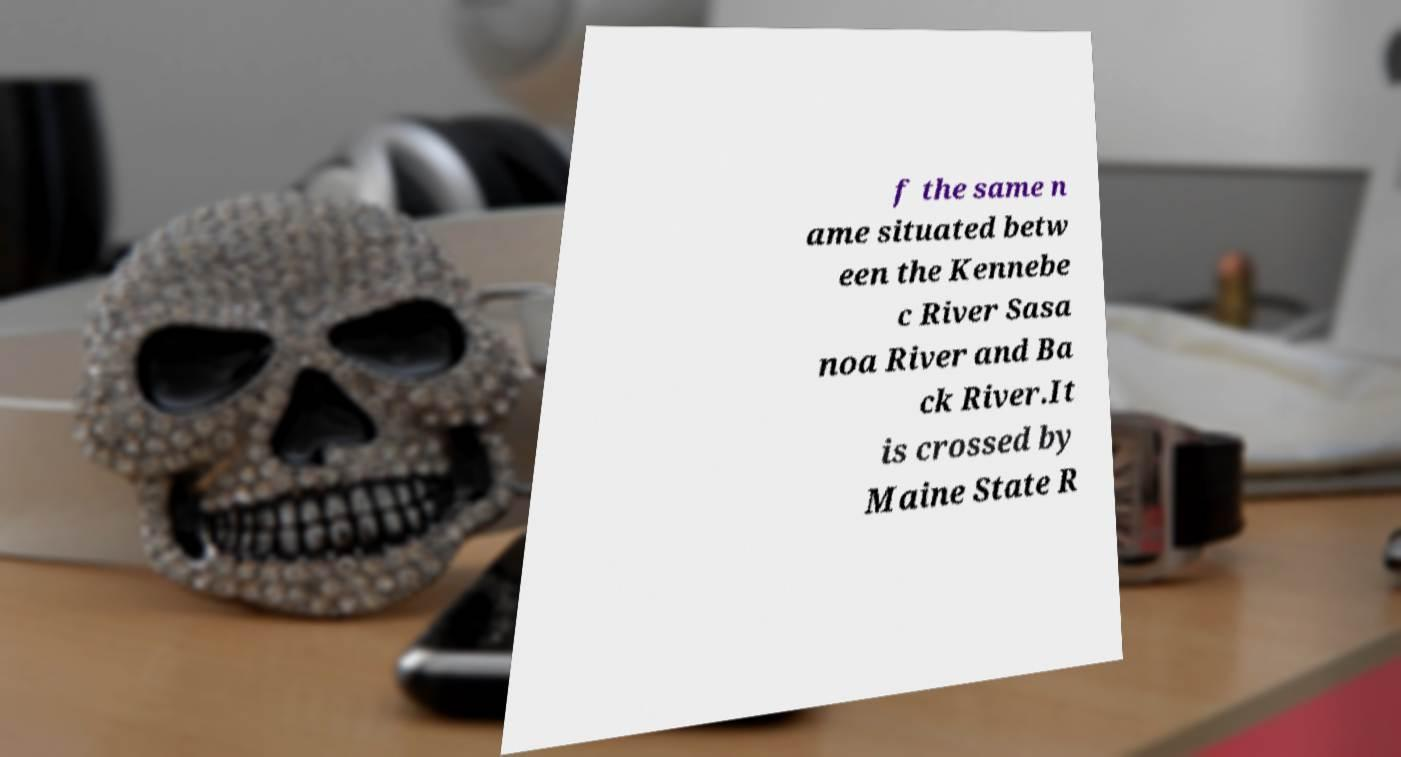Could you extract and type out the text from this image? f the same n ame situated betw een the Kennebe c River Sasa noa River and Ba ck River.It is crossed by Maine State R 